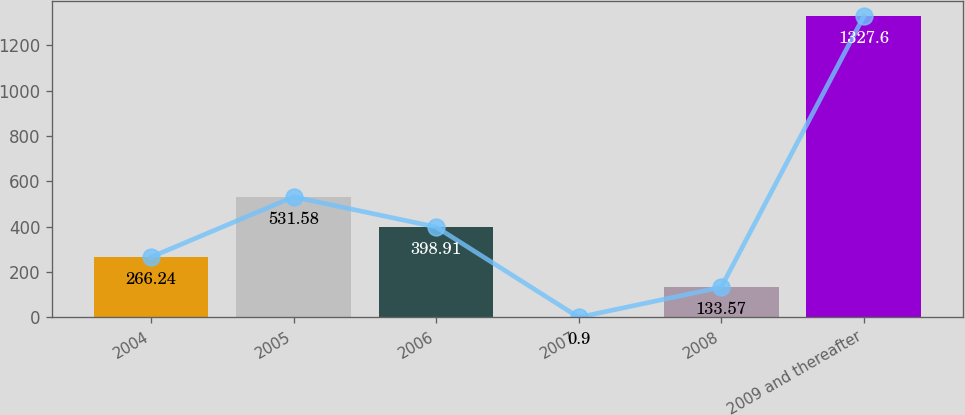Convert chart. <chart><loc_0><loc_0><loc_500><loc_500><bar_chart><fcel>2004<fcel>2005<fcel>2006<fcel>2007<fcel>2008<fcel>2009 and thereafter<nl><fcel>266.24<fcel>531.58<fcel>398.91<fcel>0.9<fcel>133.57<fcel>1327.6<nl></chart> 